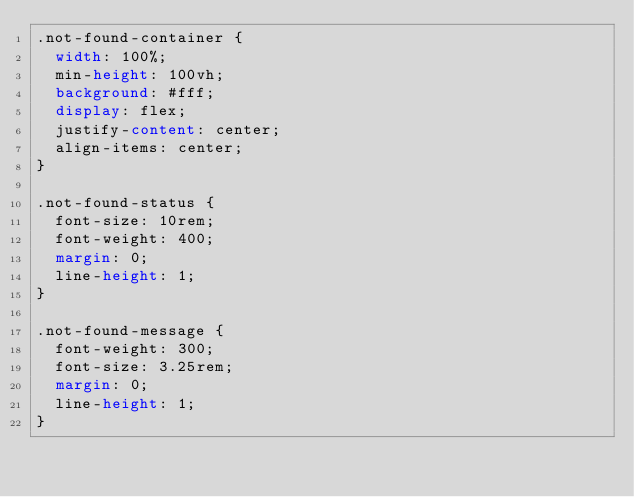Convert code to text. <code><loc_0><loc_0><loc_500><loc_500><_CSS_>.not-found-container {
  width: 100%;
  min-height: 100vh;
  background: #fff;
  display: flex;
  justify-content: center;
  align-items: center;
}

.not-found-status {
  font-size: 10rem;
  font-weight: 400;
  margin: 0;
  line-height: 1;
}

.not-found-message {
  font-weight: 300;
  font-size: 3.25rem;
  margin: 0;
  line-height: 1;
}
</code> 